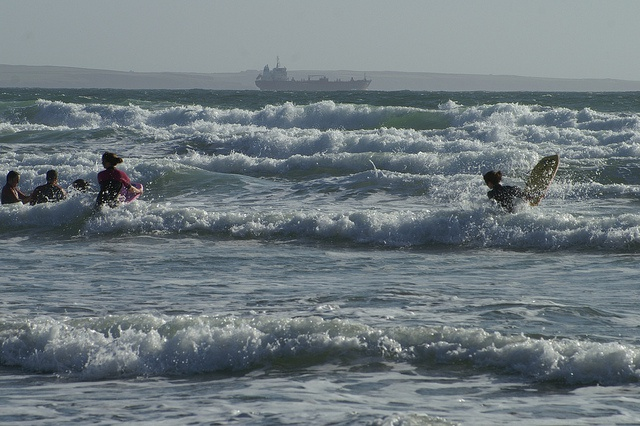Describe the objects in this image and their specific colors. I can see boat in darkgray and gray tones, people in darkgray, black, and gray tones, people in darkgray, black, gray, and maroon tones, surfboard in darkgray, black, gray, and darkgreen tones, and people in darkgray, black, and gray tones in this image. 